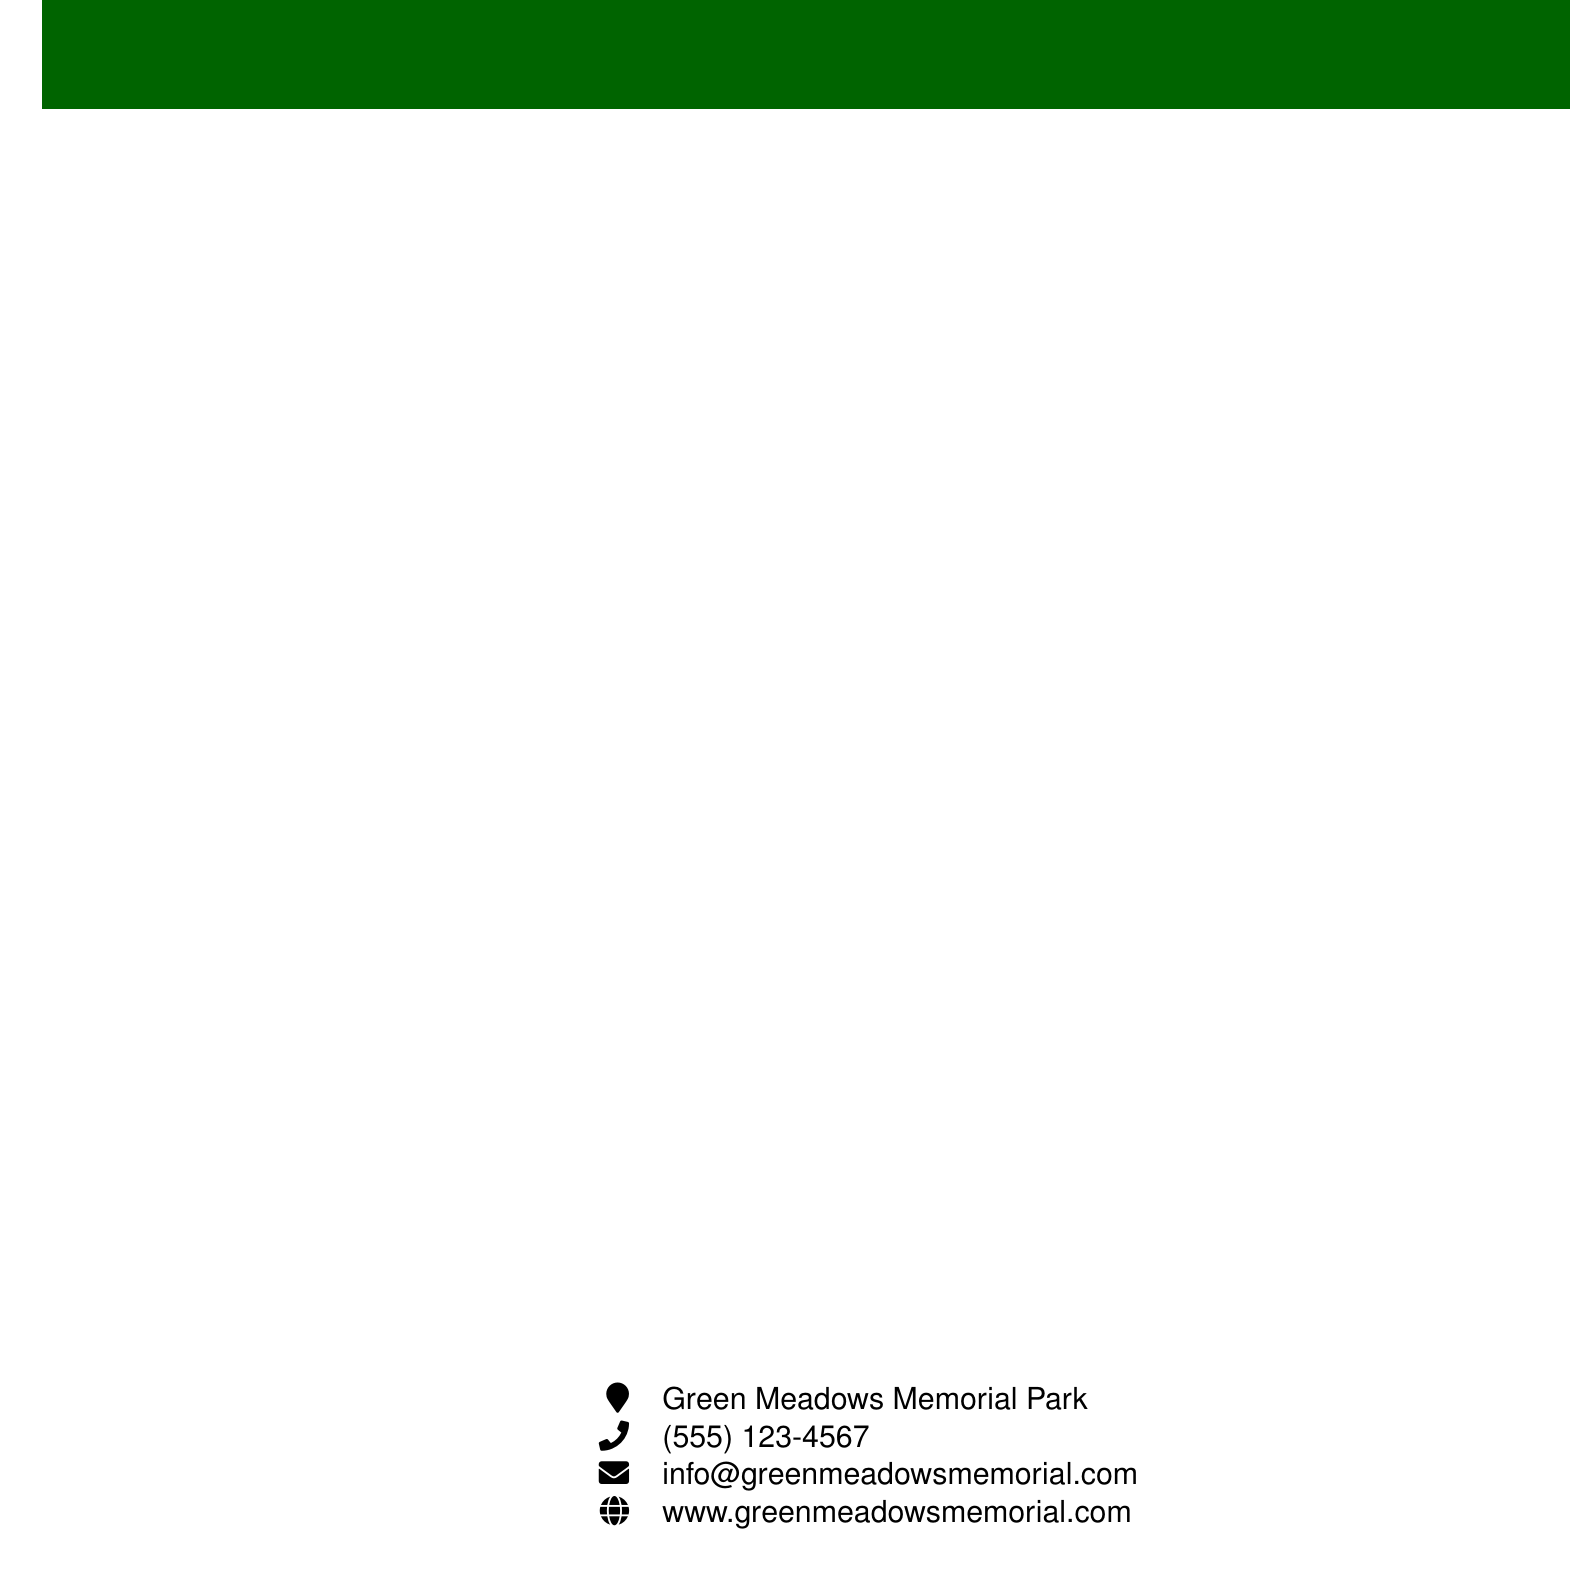What is the name of the rainwater harvesting system? The document mentions AquaCollect 5000 as the name of the rainwater harvesting system.
Answer: AquaCollect 5000 How much energy does Aquamation use compared to traditional cremation? The document states that Aquamation uses 90% less energy than traditional cremation.
Answer: 90% less energy What warranty period does SolarPath Pro offer? According to the document, SolarPath Pro comes with a 5-year warranty.
Answer: 5-year warranty What type of light does LumiGrave provide? The document describes LumiGrave Accent Lights as providing soft, warm white LED light.
Answer: soft, warm white LED How many gallons of water can AquaCollect 5000 store? The document states that AquaCollect 5000 has a storage capacity of 5000 gallons.
Answer: 5000 gallons Which eco-friendly service transforms bodies into soil? The document mentions Recompose Human Composting as the service that transforms bodies into soil.
Answer: Recompose Human Composting What is included with GreenFlush Facilities? The document indicates that Eco-friendly cleaning products are included with GreenFlush Facilities.
Answer: Eco-friendly cleaning products What type of system is Aquamation? According to the document, Aquamation is a water-based alternative to flame cremation.
Answer: water-based alternative to flame cremation What type of lighting is used in SolarPath Pro? The document specifies that SolarPath Pro uses durable, weather-resistant LED lights.
Answer: LED lights 